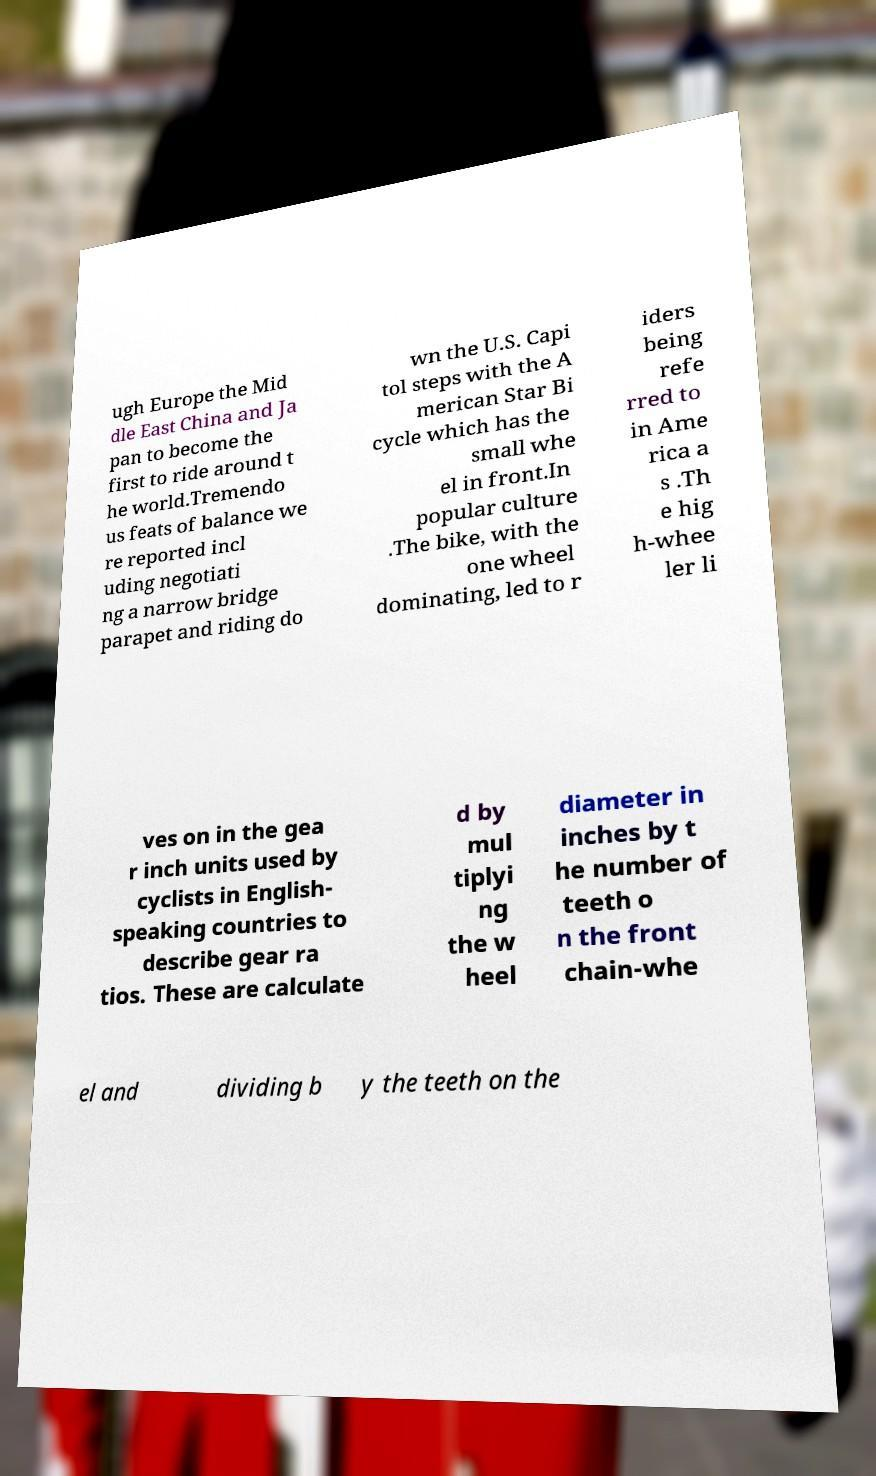I need the written content from this picture converted into text. Can you do that? ugh Europe the Mid dle East China and Ja pan to become the first to ride around t he world.Tremendo us feats of balance we re reported incl uding negotiati ng a narrow bridge parapet and riding do wn the U.S. Capi tol steps with the A merican Star Bi cycle which has the small whe el in front.In popular culture .The bike, with the one wheel dominating, led to r iders being refe rred to in Ame rica a s .Th e hig h-whee ler li ves on in the gea r inch units used by cyclists in English- speaking countries to describe gear ra tios. These are calculate d by mul tiplyi ng the w heel diameter in inches by t he number of teeth o n the front chain-whe el and dividing b y the teeth on the 